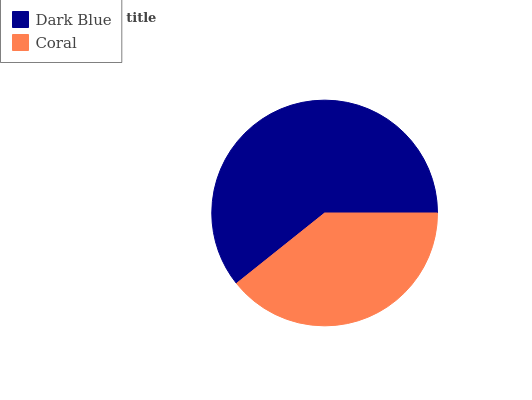Is Coral the minimum?
Answer yes or no. Yes. Is Dark Blue the maximum?
Answer yes or no. Yes. Is Coral the maximum?
Answer yes or no. No. Is Dark Blue greater than Coral?
Answer yes or no. Yes. Is Coral less than Dark Blue?
Answer yes or no. Yes. Is Coral greater than Dark Blue?
Answer yes or no. No. Is Dark Blue less than Coral?
Answer yes or no. No. Is Dark Blue the high median?
Answer yes or no. Yes. Is Coral the low median?
Answer yes or no. Yes. Is Coral the high median?
Answer yes or no. No. Is Dark Blue the low median?
Answer yes or no. No. 